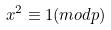<formula> <loc_0><loc_0><loc_500><loc_500>x ^ { 2 } \equiv 1 ( m o d p )</formula> 